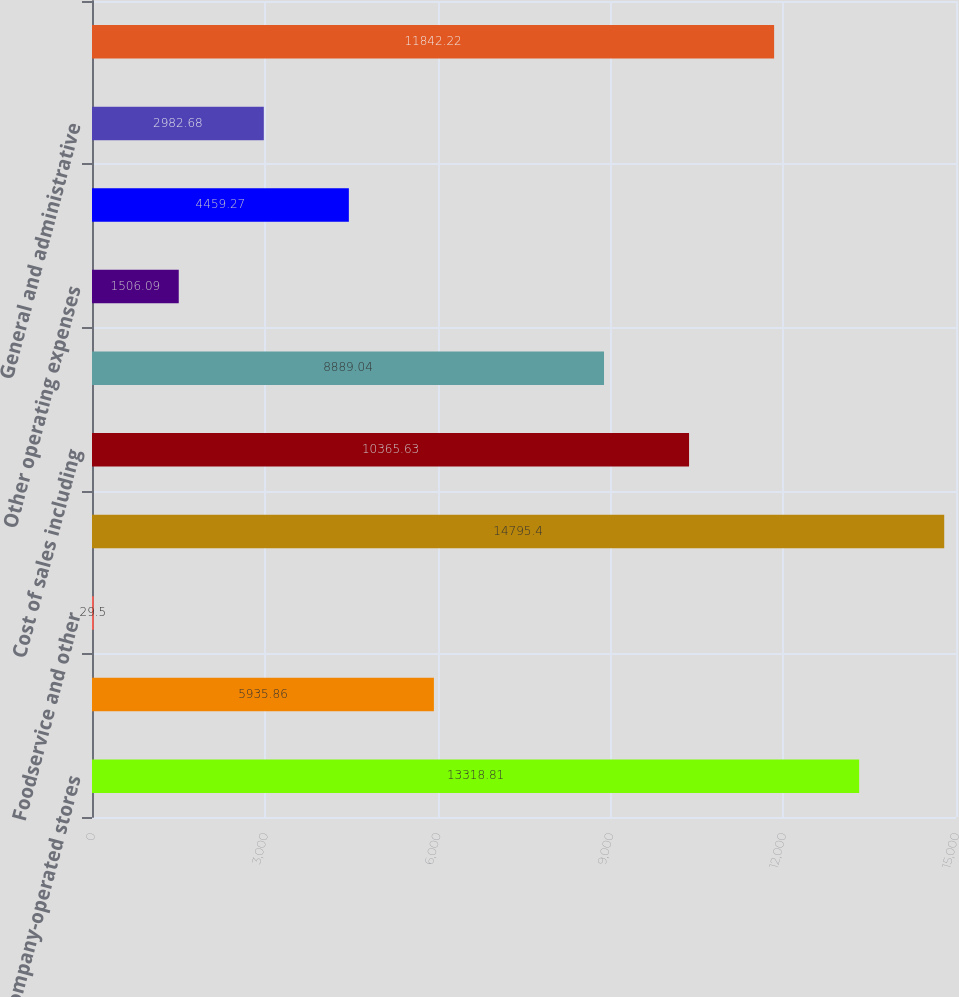Convert chart to OTSL. <chart><loc_0><loc_0><loc_500><loc_500><bar_chart><fcel>Company-operated stores<fcel>Licensed stores<fcel>Foodservice and other<fcel>Total net revenues<fcel>Cost of sales including<fcel>Store operating expenses<fcel>Other operating expenses<fcel>Depreciation and amortization<fcel>General and administrative<fcel>Total operating expenses<nl><fcel>13318.8<fcel>5935.86<fcel>29.5<fcel>14795.4<fcel>10365.6<fcel>8889.04<fcel>1506.09<fcel>4459.27<fcel>2982.68<fcel>11842.2<nl></chart> 